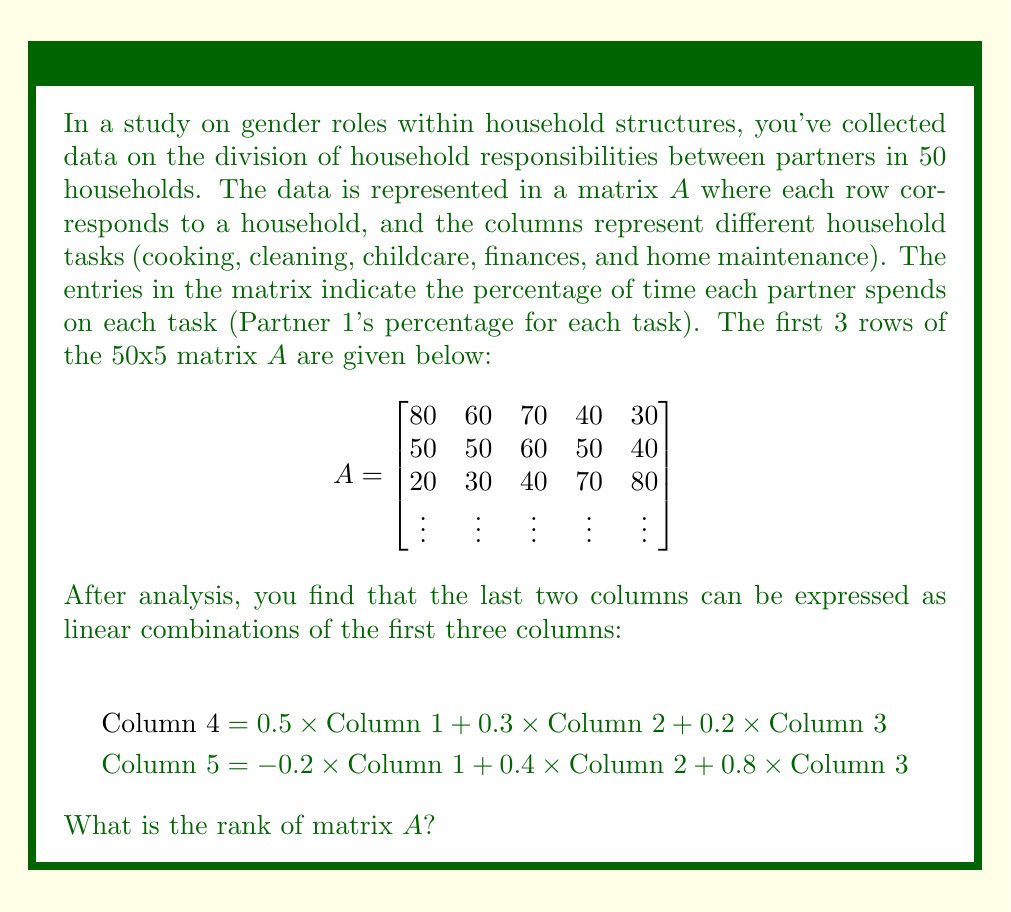Could you help me with this problem? To find the rank of matrix $A$, we need to determine the number of linearly independent columns or rows in the matrix. From the information given, we can deduce the following:

1) The matrix $A$ has 5 columns in total.

2) We are told that the last two columns (columns 4 and 5) can be expressed as linear combinations of the first three columns. This means that these two columns are linearly dependent on the first three.

3) To check if the first three columns are linearly independent, we need to look at the given equations:

   Column 4 = 0.5 * Column 1 + 0.3 * Column 2 + 0.2 * Column 3
   Column 5 = -0.2 * Column 1 + 0.4 * Column 2 + 0.8 * Column 3

   These equations use non-zero coefficients for each of the first three columns, which suggests that none of these columns can be expressed as a linear combination of the others. If they could, one of the coefficients would be zero in both equations.

4) Therefore, we can conclude that the first three columns are linearly independent.

5) The rank of a matrix is equal to the number of linearly independent columns (or rows).

Given this analysis, we can determine that the first three columns of matrix $A$ form a basis for its column space, while the last two columns are linear combinations of this basis.
Answer: The rank of matrix $A$ is 3. 